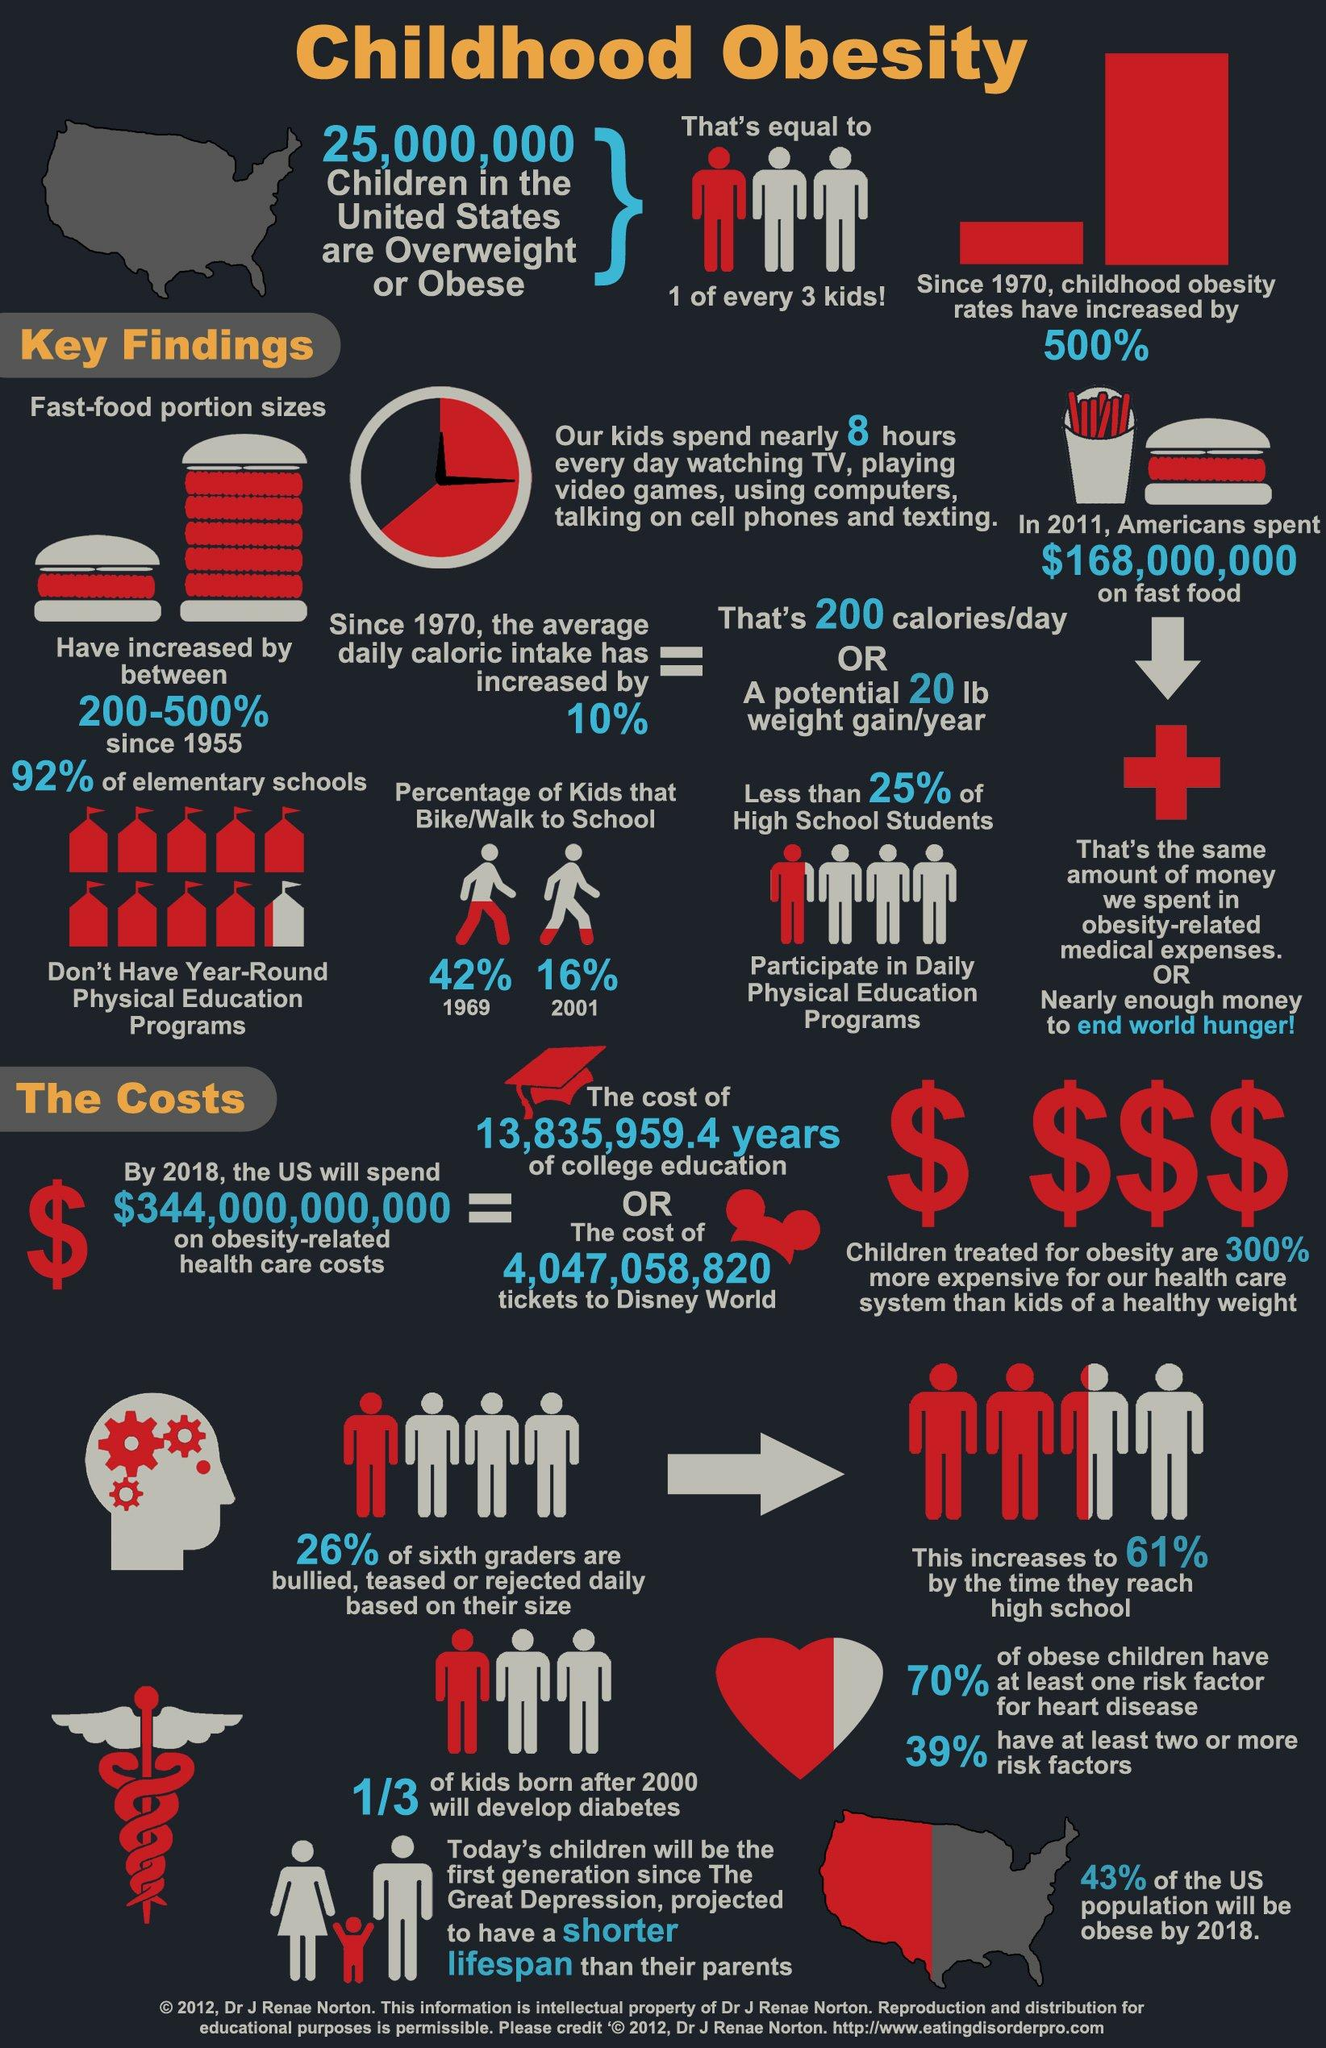List a handful of essential elements in this visual. The proportion of children who walk or cycle to school has decreased by 26% from 1969 to 2001. 